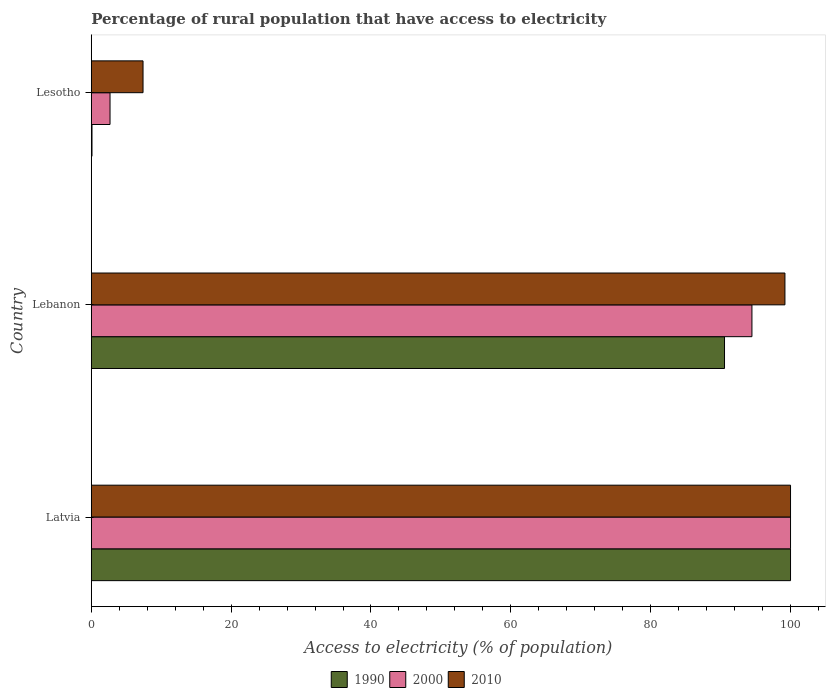How many groups of bars are there?
Provide a succinct answer. 3. Are the number of bars on each tick of the Y-axis equal?
Keep it short and to the point. Yes. How many bars are there on the 1st tick from the top?
Make the answer very short. 3. How many bars are there on the 2nd tick from the bottom?
Offer a terse response. 3. What is the label of the 3rd group of bars from the top?
Offer a very short reply. Latvia. In how many cases, is the number of bars for a given country not equal to the number of legend labels?
Offer a very short reply. 0. What is the percentage of rural population that have access to electricity in 1990 in Latvia?
Ensure brevity in your answer.  100. Across all countries, what is the maximum percentage of rural population that have access to electricity in 2010?
Your response must be concise. 100. Across all countries, what is the minimum percentage of rural population that have access to electricity in 2010?
Provide a succinct answer. 7.4. In which country was the percentage of rural population that have access to electricity in 1990 maximum?
Give a very brief answer. Latvia. In which country was the percentage of rural population that have access to electricity in 2010 minimum?
Ensure brevity in your answer.  Lesotho. What is the total percentage of rural population that have access to electricity in 2010 in the graph?
Offer a terse response. 206.6. What is the difference between the percentage of rural population that have access to electricity in 2010 in Lebanon and that in Lesotho?
Provide a succinct answer. 91.8. What is the difference between the percentage of rural population that have access to electricity in 1990 in Lesotho and the percentage of rural population that have access to electricity in 2000 in Latvia?
Give a very brief answer. -99.9. What is the average percentage of rural population that have access to electricity in 1990 per country?
Your response must be concise. 63.55. What is the difference between the percentage of rural population that have access to electricity in 2010 and percentage of rural population that have access to electricity in 2000 in Lebanon?
Offer a very short reply. 4.72. In how many countries, is the percentage of rural population that have access to electricity in 2010 greater than 32 %?
Your response must be concise. 2. What is the ratio of the percentage of rural population that have access to electricity in 2000 in Latvia to that in Lebanon?
Give a very brief answer. 1.06. Is the difference between the percentage of rural population that have access to electricity in 2010 in Latvia and Lebanon greater than the difference between the percentage of rural population that have access to electricity in 2000 in Latvia and Lebanon?
Provide a succinct answer. No. What is the difference between the highest and the second highest percentage of rural population that have access to electricity in 2010?
Provide a succinct answer. 0.8. What is the difference between the highest and the lowest percentage of rural population that have access to electricity in 2010?
Provide a short and direct response. 92.6. Is the sum of the percentage of rural population that have access to electricity in 1990 in Lebanon and Lesotho greater than the maximum percentage of rural population that have access to electricity in 2010 across all countries?
Your response must be concise. No. Is it the case that in every country, the sum of the percentage of rural population that have access to electricity in 2010 and percentage of rural population that have access to electricity in 2000 is greater than the percentage of rural population that have access to electricity in 1990?
Provide a short and direct response. Yes. How many bars are there?
Ensure brevity in your answer.  9. Does the graph contain grids?
Your answer should be compact. No. What is the title of the graph?
Ensure brevity in your answer.  Percentage of rural population that have access to electricity. Does "1976" appear as one of the legend labels in the graph?
Offer a terse response. No. What is the label or title of the X-axis?
Ensure brevity in your answer.  Access to electricity (% of population). What is the label or title of the Y-axis?
Provide a succinct answer. Country. What is the Access to electricity (% of population) of 1990 in Latvia?
Provide a succinct answer. 100. What is the Access to electricity (% of population) in 2000 in Latvia?
Your response must be concise. 100. What is the Access to electricity (% of population) in 1990 in Lebanon?
Your answer should be compact. 90.56. What is the Access to electricity (% of population) of 2000 in Lebanon?
Offer a very short reply. 94.48. What is the Access to electricity (% of population) of 2010 in Lebanon?
Your response must be concise. 99.2. What is the Access to electricity (% of population) in 1990 in Lesotho?
Give a very brief answer. 0.1. What is the Access to electricity (% of population) in 2000 in Lesotho?
Your response must be concise. 2.68. What is the Access to electricity (% of population) in 2010 in Lesotho?
Keep it short and to the point. 7.4. Across all countries, what is the maximum Access to electricity (% of population) in 2000?
Make the answer very short. 100. Across all countries, what is the maximum Access to electricity (% of population) in 2010?
Provide a succinct answer. 100. Across all countries, what is the minimum Access to electricity (% of population) in 1990?
Offer a terse response. 0.1. Across all countries, what is the minimum Access to electricity (% of population) in 2000?
Keep it short and to the point. 2.68. Across all countries, what is the minimum Access to electricity (% of population) in 2010?
Your answer should be compact. 7.4. What is the total Access to electricity (% of population) in 1990 in the graph?
Make the answer very short. 190.66. What is the total Access to electricity (% of population) of 2000 in the graph?
Give a very brief answer. 197.16. What is the total Access to electricity (% of population) of 2010 in the graph?
Provide a succinct answer. 206.6. What is the difference between the Access to electricity (% of population) in 1990 in Latvia and that in Lebanon?
Ensure brevity in your answer.  9.44. What is the difference between the Access to electricity (% of population) of 2000 in Latvia and that in Lebanon?
Make the answer very short. 5.52. What is the difference between the Access to electricity (% of population) in 1990 in Latvia and that in Lesotho?
Keep it short and to the point. 99.9. What is the difference between the Access to electricity (% of population) in 2000 in Latvia and that in Lesotho?
Provide a succinct answer. 97.32. What is the difference between the Access to electricity (% of population) of 2010 in Latvia and that in Lesotho?
Make the answer very short. 92.6. What is the difference between the Access to electricity (% of population) in 1990 in Lebanon and that in Lesotho?
Offer a terse response. 90.46. What is the difference between the Access to electricity (% of population) in 2000 in Lebanon and that in Lesotho?
Your answer should be very brief. 91.8. What is the difference between the Access to electricity (% of population) in 2010 in Lebanon and that in Lesotho?
Give a very brief answer. 91.8. What is the difference between the Access to electricity (% of population) of 1990 in Latvia and the Access to electricity (% of population) of 2000 in Lebanon?
Your answer should be very brief. 5.52. What is the difference between the Access to electricity (% of population) in 1990 in Latvia and the Access to electricity (% of population) in 2000 in Lesotho?
Give a very brief answer. 97.32. What is the difference between the Access to electricity (% of population) of 1990 in Latvia and the Access to electricity (% of population) of 2010 in Lesotho?
Provide a short and direct response. 92.6. What is the difference between the Access to electricity (% of population) in 2000 in Latvia and the Access to electricity (% of population) in 2010 in Lesotho?
Provide a short and direct response. 92.6. What is the difference between the Access to electricity (% of population) in 1990 in Lebanon and the Access to electricity (% of population) in 2000 in Lesotho?
Offer a terse response. 87.88. What is the difference between the Access to electricity (% of population) in 1990 in Lebanon and the Access to electricity (% of population) in 2010 in Lesotho?
Your answer should be compact. 83.16. What is the difference between the Access to electricity (% of population) of 2000 in Lebanon and the Access to electricity (% of population) of 2010 in Lesotho?
Provide a short and direct response. 87.08. What is the average Access to electricity (% of population) of 1990 per country?
Your response must be concise. 63.55. What is the average Access to electricity (% of population) in 2000 per country?
Offer a very short reply. 65.72. What is the average Access to electricity (% of population) in 2010 per country?
Ensure brevity in your answer.  68.87. What is the difference between the Access to electricity (% of population) of 2000 and Access to electricity (% of population) of 2010 in Latvia?
Your response must be concise. 0. What is the difference between the Access to electricity (% of population) of 1990 and Access to electricity (% of population) of 2000 in Lebanon?
Keep it short and to the point. -3.92. What is the difference between the Access to electricity (% of population) in 1990 and Access to electricity (% of population) in 2010 in Lebanon?
Your response must be concise. -8.64. What is the difference between the Access to electricity (% of population) of 2000 and Access to electricity (% of population) of 2010 in Lebanon?
Provide a succinct answer. -4.72. What is the difference between the Access to electricity (% of population) of 1990 and Access to electricity (% of population) of 2000 in Lesotho?
Your response must be concise. -2.58. What is the difference between the Access to electricity (% of population) of 2000 and Access to electricity (% of population) of 2010 in Lesotho?
Your answer should be very brief. -4.72. What is the ratio of the Access to electricity (% of population) of 1990 in Latvia to that in Lebanon?
Provide a succinct answer. 1.1. What is the ratio of the Access to electricity (% of population) of 2000 in Latvia to that in Lebanon?
Offer a very short reply. 1.06. What is the ratio of the Access to electricity (% of population) of 2010 in Latvia to that in Lebanon?
Provide a succinct answer. 1.01. What is the ratio of the Access to electricity (% of population) in 2000 in Latvia to that in Lesotho?
Give a very brief answer. 37.3. What is the ratio of the Access to electricity (% of population) in 2010 in Latvia to that in Lesotho?
Offer a very short reply. 13.51. What is the ratio of the Access to electricity (% of population) in 1990 in Lebanon to that in Lesotho?
Offer a very short reply. 905.6. What is the ratio of the Access to electricity (% of population) of 2000 in Lebanon to that in Lesotho?
Keep it short and to the point. 35.25. What is the ratio of the Access to electricity (% of population) in 2010 in Lebanon to that in Lesotho?
Offer a terse response. 13.41. What is the difference between the highest and the second highest Access to electricity (% of population) in 1990?
Offer a terse response. 9.44. What is the difference between the highest and the second highest Access to electricity (% of population) of 2000?
Provide a succinct answer. 5.52. What is the difference between the highest and the lowest Access to electricity (% of population) in 1990?
Ensure brevity in your answer.  99.9. What is the difference between the highest and the lowest Access to electricity (% of population) of 2000?
Your answer should be compact. 97.32. What is the difference between the highest and the lowest Access to electricity (% of population) in 2010?
Your answer should be very brief. 92.6. 